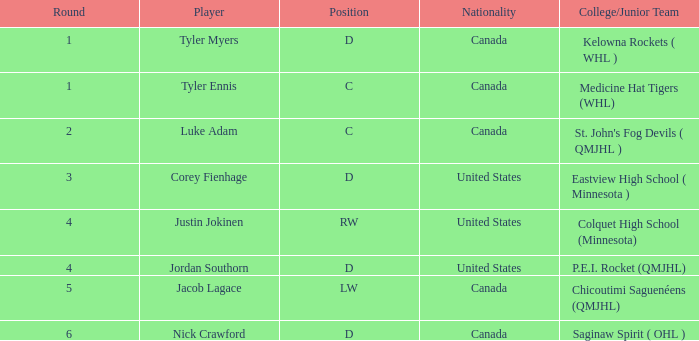What is the aggregate sum of the picked left-winger? 134.0. 